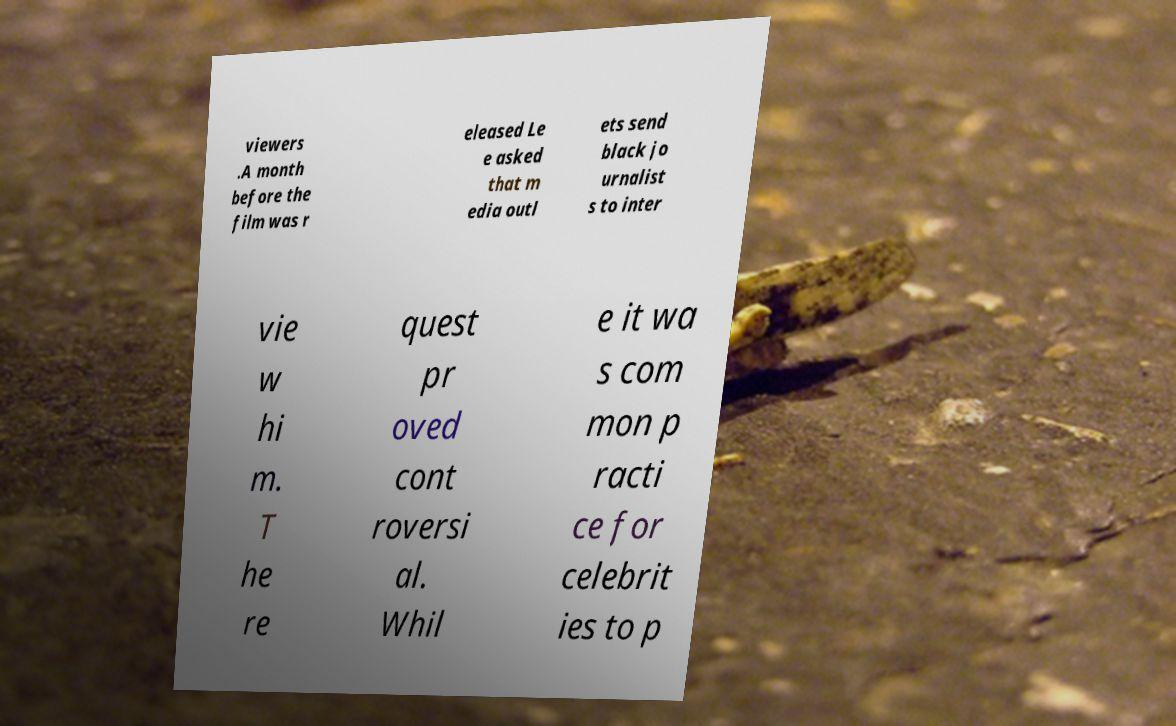What messages or text are displayed in this image? I need them in a readable, typed format. viewers .A month before the film was r eleased Le e asked that m edia outl ets send black jo urnalist s to inter vie w hi m. T he re quest pr oved cont roversi al. Whil e it wa s com mon p racti ce for celebrit ies to p 